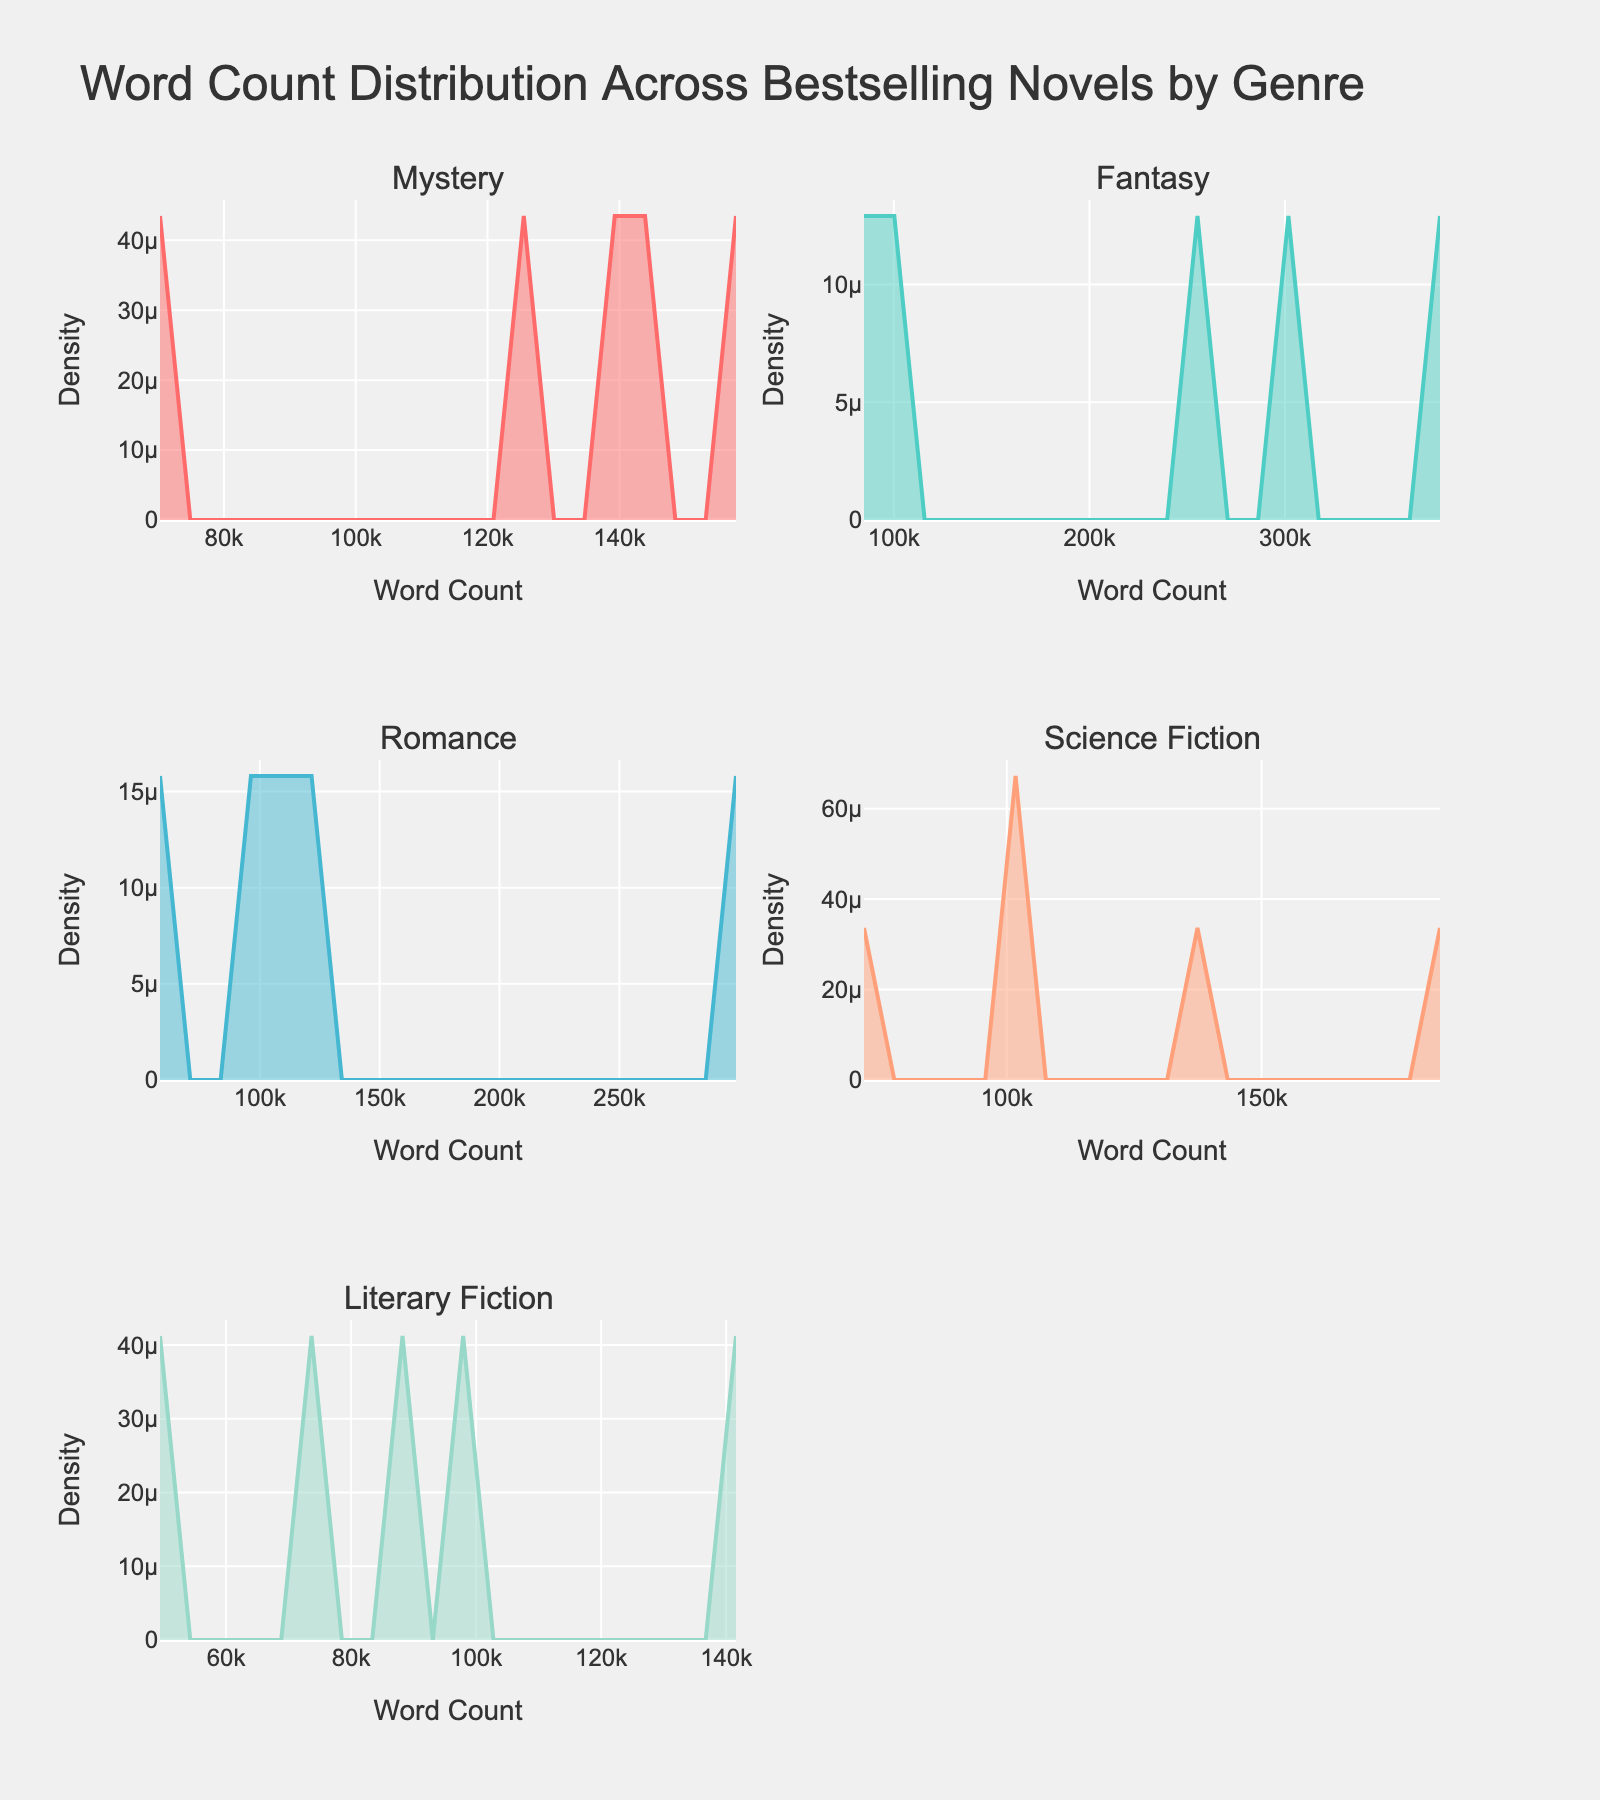What is the title of the figure? The title is usually positioned at the top of the figure. In this case, it states what the data is about.
Answer: Word Count Distribution Across Bestselling Novels by Genre Which genre has the highest peak in the density plot? The highest peak can be identified where the density line reaches its maximum value on the y-axis.
Answer: Fantasy How does the word count distribution of Mystery novels compare to Romance novels? Compare the density curves of Mystery and Romance genres. Mystery novels have peaks at higher word counts compared to Romance novels which have a lower peak.
Answer: Mystery novels have higher word counts What is the range of word counts for Science Fiction novels? Look at the x-axis range where the density for Science Fiction is non-zero. Science Fiction densities start close to 50k and end close to 200k.
Answer: Approximately 50,000 to 200,000 Which genre shows the most variability in word counts? Variability can be understood by the spread of the density curve. A wider curve indicates higher variability. Fantasy has the widest spread.
Answer: Fantasy What can you infer about the word counts for Literary Fiction novels? Literary Fiction's density plot should have its peak and spread indicated by its curve on the top right subplot.
Answer: Covers smaller word counts, peaks around 100,000 Between Mystery and Science Fiction, which genre has a more concentrated word count distribution? A more concentrated distribution will have a narrower peak. Compare the widths of peaks in the Mystery and Science Fiction subplots.
Answer: Science Fiction How many genres are plotted in the subplots? The subplots each represent a different genre. Count the subplot titles or the number of curves.
Answer: Five What is the primary difference in word count distribution between Fantasy and Romance novels? Observe the density plots for Fantasy and Romance. Fantasy novels show high word counts with several peaks, while Romance novels show lower word counts concentrated around one peak.
Answer: Fantasy novels have higher and more variable word counts 